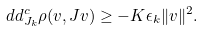<formula> <loc_0><loc_0><loc_500><loc_500>d d ^ { c } _ { J _ { k } } \rho ( v , J v ) \geq - K \epsilon _ { k } \| v \| ^ { 2 } .</formula> 